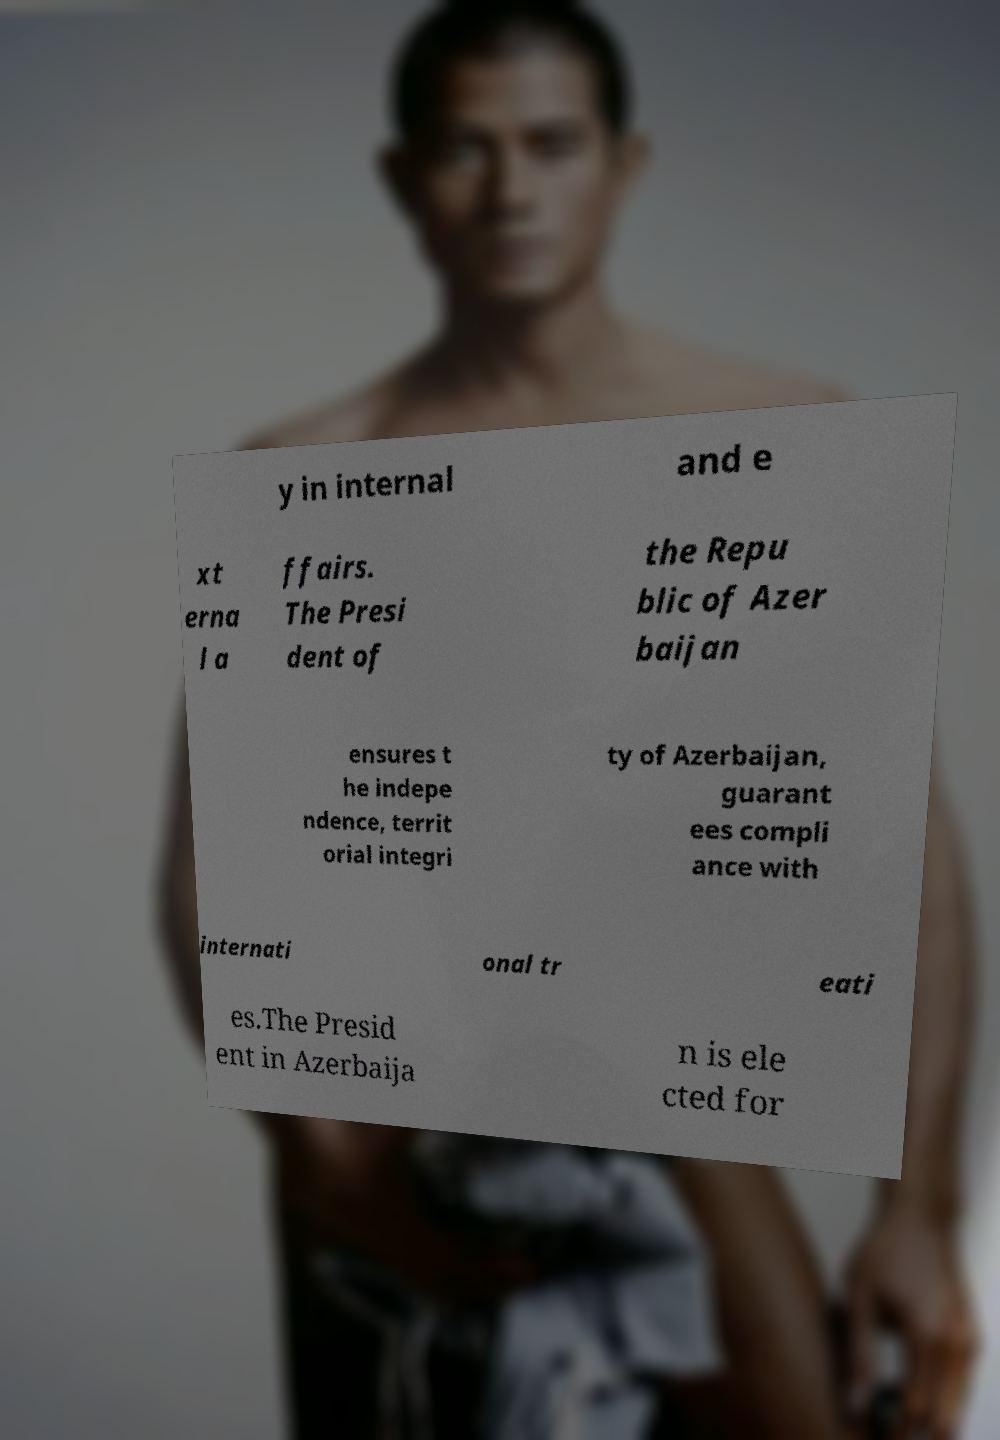Please identify and transcribe the text found in this image. y in internal and e xt erna l a ffairs. The Presi dent of the Repu blic of Azer baijan ensures t he indepe ndence, territ orial integri ty of Azerbaijan, guarant ees compli ance with internati onal tr eati es.The Presid ent in Azerbaija n is ele cted for 